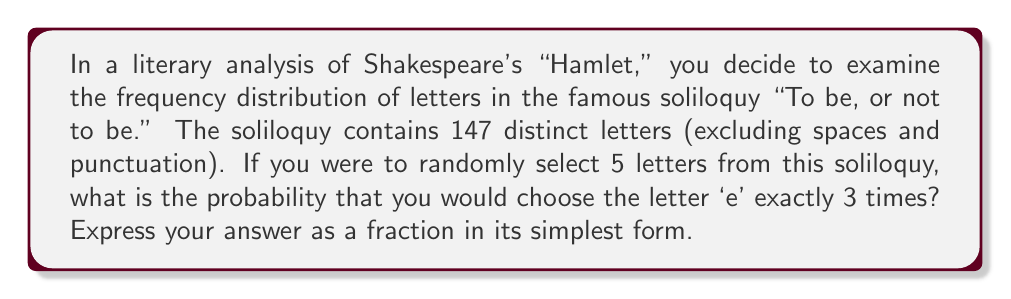What is the answer to this math problem? Let's approach this step-by-step:

1) First, we need to count the number of 'e's in the soliloquy. In "To be, or not to be," there are 13 'e's out of 147 letters.

2) This scenario follows a binomial probability distribution. We can use the binomial probability formula:

   $$P(X = k) = \binom{n}{k} p^k (1-p)^{n-k}$$

   Where:
   $n$ = number of trials (5 in this case)
   $k$ = number of successes (3 in this case)
   $p$ = probability of success on each trial (13/147 in this case)

3) Let's calculate each part:

   $\binom{5}{3} = 10$

   $p = \frac{13}{147}$

   $1-p = \frac{134}{147}$

4) Substituting into the formula:

   $$P(X = 3) = 10 \cdot (\frac{13}{147})^3 \cdot (\frac{134}{147})^2$$

5) Simplifying:

   $$P(X = 3) = 10 \cdot \frac{2197}{3176523} \cdot \frac{17956}{21609}$$

6) Multiplying all terms:

   $$P(X = 3) = \frac{394132120}{68659537647}$$

This fraction is already in its simplest form.
Answer: $\frac{394132120}{68659537647}$ 